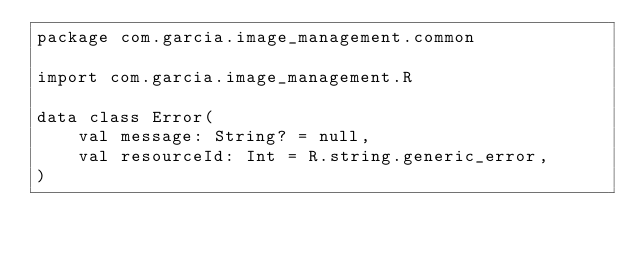Convert code to text. <code><loc_0><loc_0><loc_500><loc_500><_Kotlin_>package com.garcia.image_management.common

import com.garcia.image_management.R

data class Error(
    val message: String? = null,
    val resourceId: Int = R.string.generic_error,
)</code> 